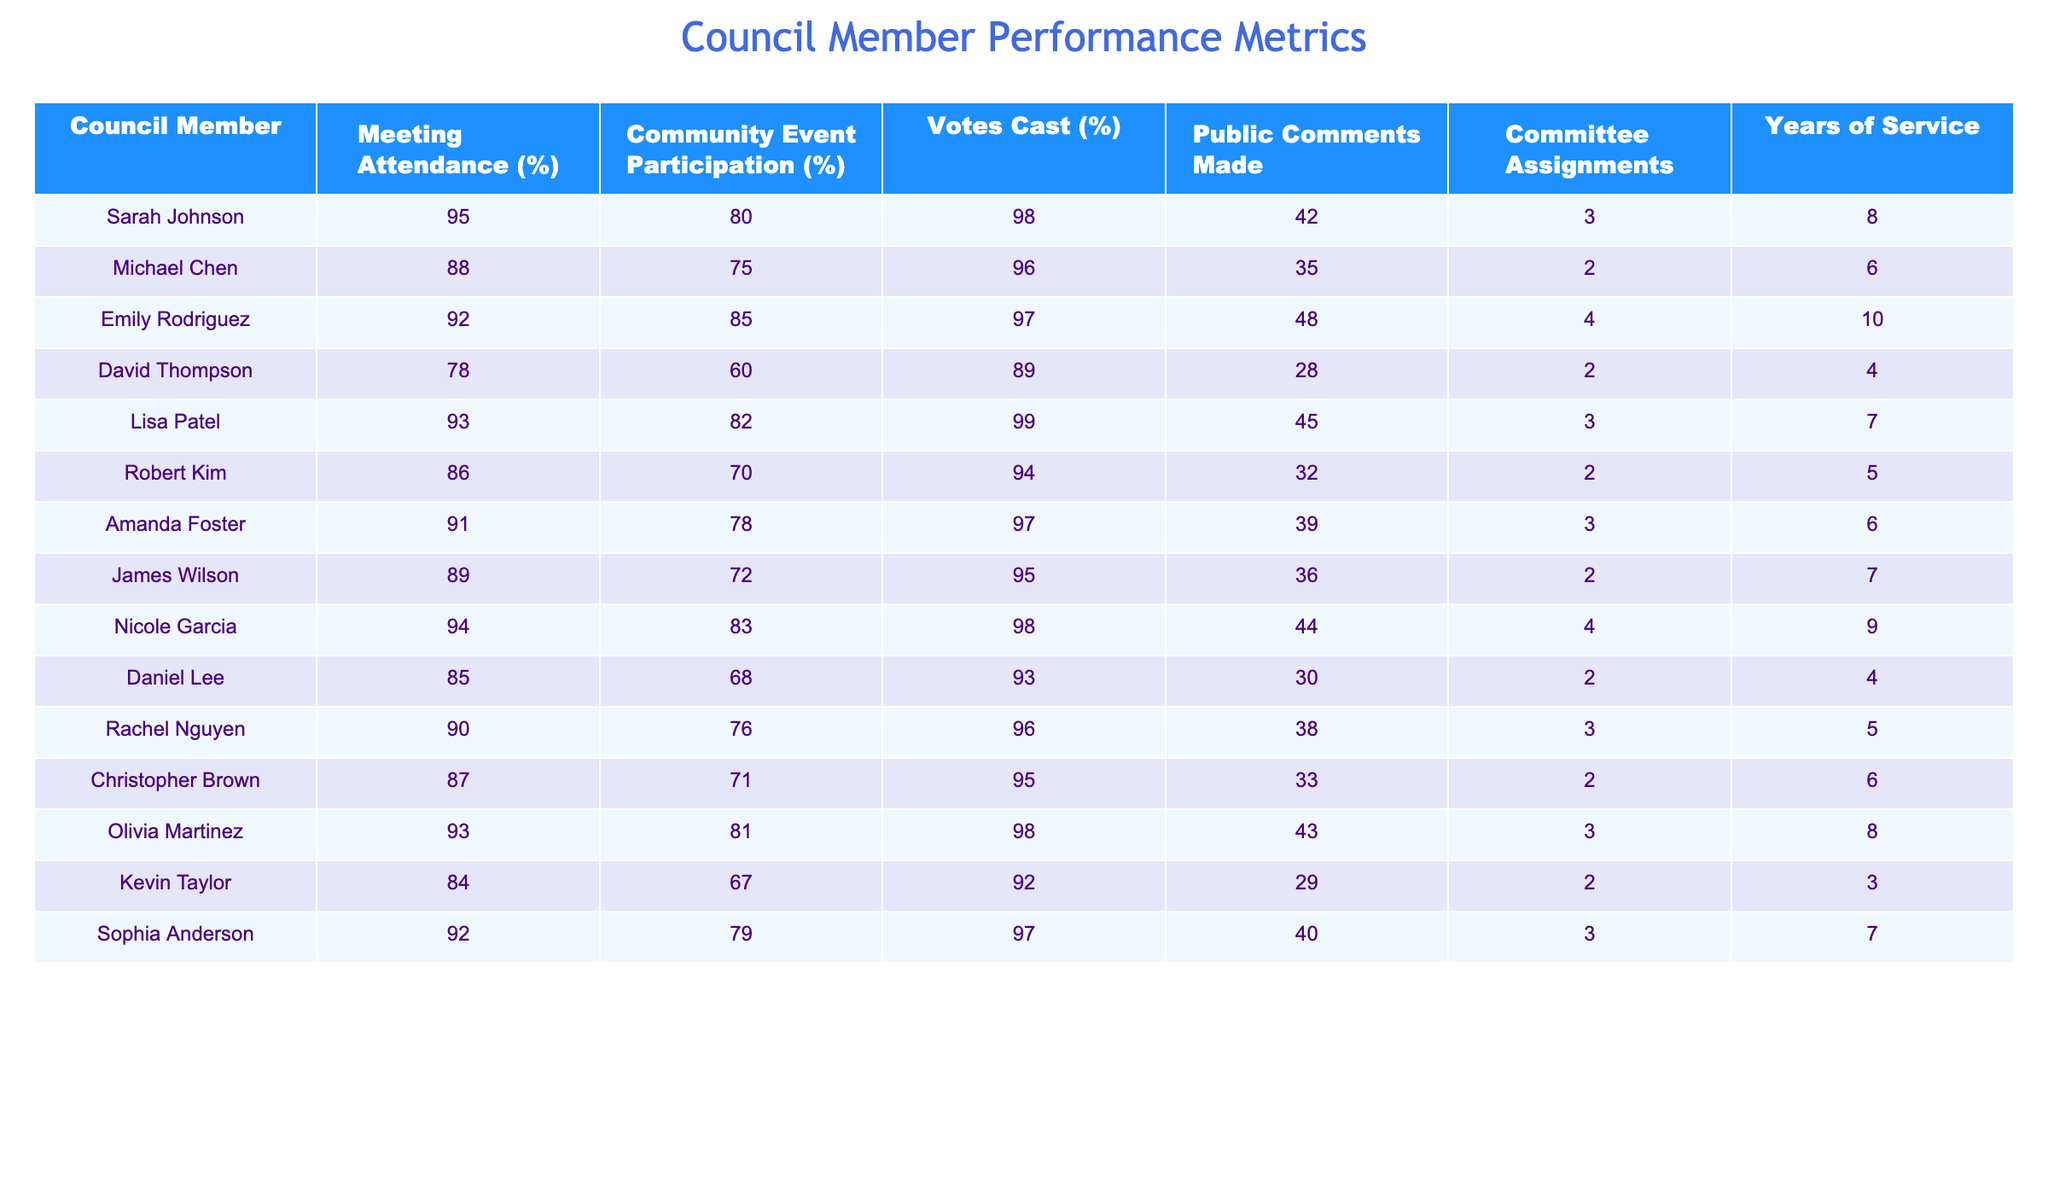What is the meeting attendance percentage for Sarah Johnson? The table lists Sarah Johnson's meeting attendance percentage directly. It shows "95" under the "Meeting Attendance (%)" column.
Answer: 95 Which council member has the highest community event participation percentage? By examining the "Community Event Participation (%)" column, we see that Emily Rodriguez has the highest percentage of "85."
Answer: Emily Rodriguez What is the average votes cast percentage for all council members? To find the average, sum the "Votes Cast (%)" values: 98 + 96 + 97 + 89 + 99 + 94 + 97 + 95 + 98 + 93 + 96 + 95 + 98 + 92 + 97 = 93.2. Divide by 15 (total members) to find the average: 93.2/15 = 93.2
Answer: 93.2 How many public comments did Amanda Foster make? The table includes a column for "Public Comments Made," where Amanda Foster has made "39" comments.
Answer: 39 Is it true that Daniel Lee has a community event participation percentage greater than 70%? Looking at Daniel Lee's row, the "Community Event Participation (%)" column shows "68," which is less than 70. Therefore, the statement is false.
Answer: No What is the difference between the highest and lowest meeting attendance percentages? The highest meeting attendance percentage is 95 (Sarah Johnson) and the lowest is 78 (David Thompson). The difference is: 95 - 78 = 17.
Answer: 17 Which council member has served the least number of years? Checking the "Years of Service" column, Kevin Taylor has served for "3" years, which is the least among all the members.
Answer: Kevin Taylor What is the combined percentage of meeting attendance and community event participation for Nicole Garcia? Nicole Garcia's meeting attendance is 94% and her community event participation is 83%. Adding these values gives: 94 + 83 = 177.
Answer: 177 How many committee assignments does Rachel Nguyen have compared to Lisa Patel? Rachel Nguyen has "3" committee assignments, while Lisa Patel has "3". Both have the same number of assignments.
Answer: Same number (3) Which council member made more public comments, David Thompson or Robert Kim? David Thompson made "28" public comments, while Robert Kim made "32." Since 32 > 28, Robert Kim made more comments.
Answer: Robert Kim 